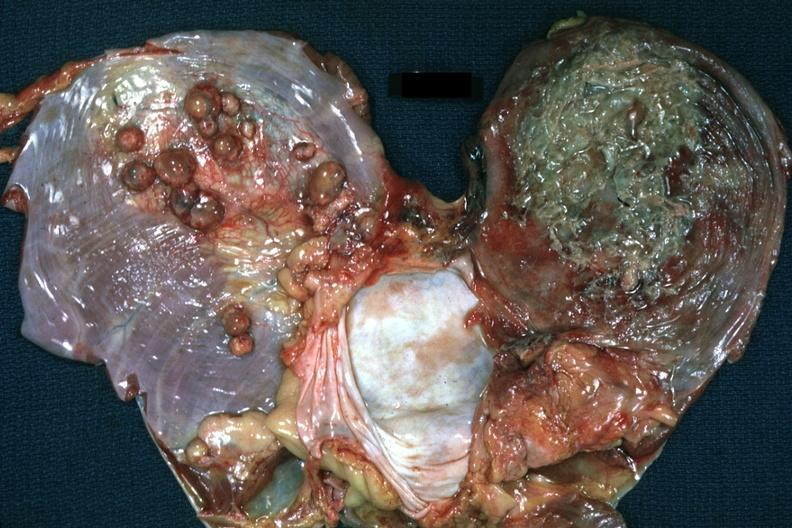s soft tissue present?
Answer the question using a single word or phrase. Yes 